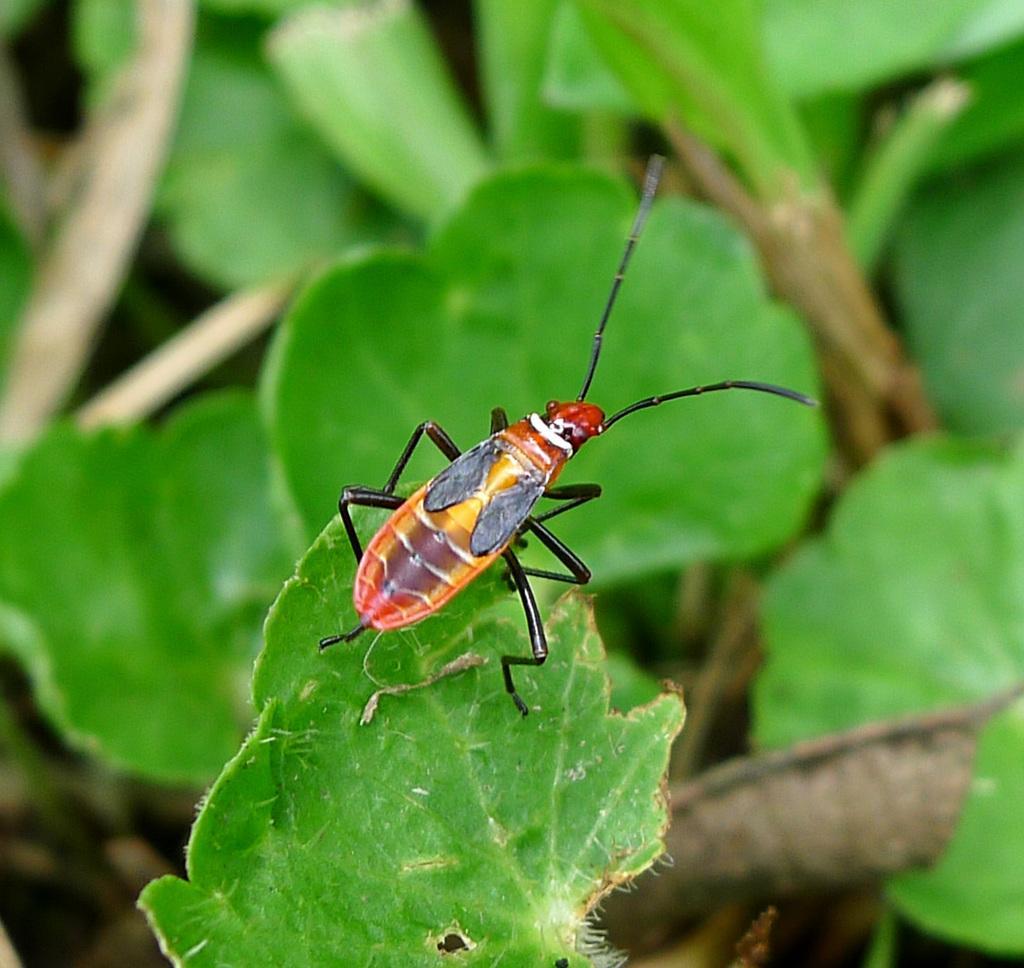Could you give a brief overview of what you see in this image? In this image, we can see some plants and an insect. 